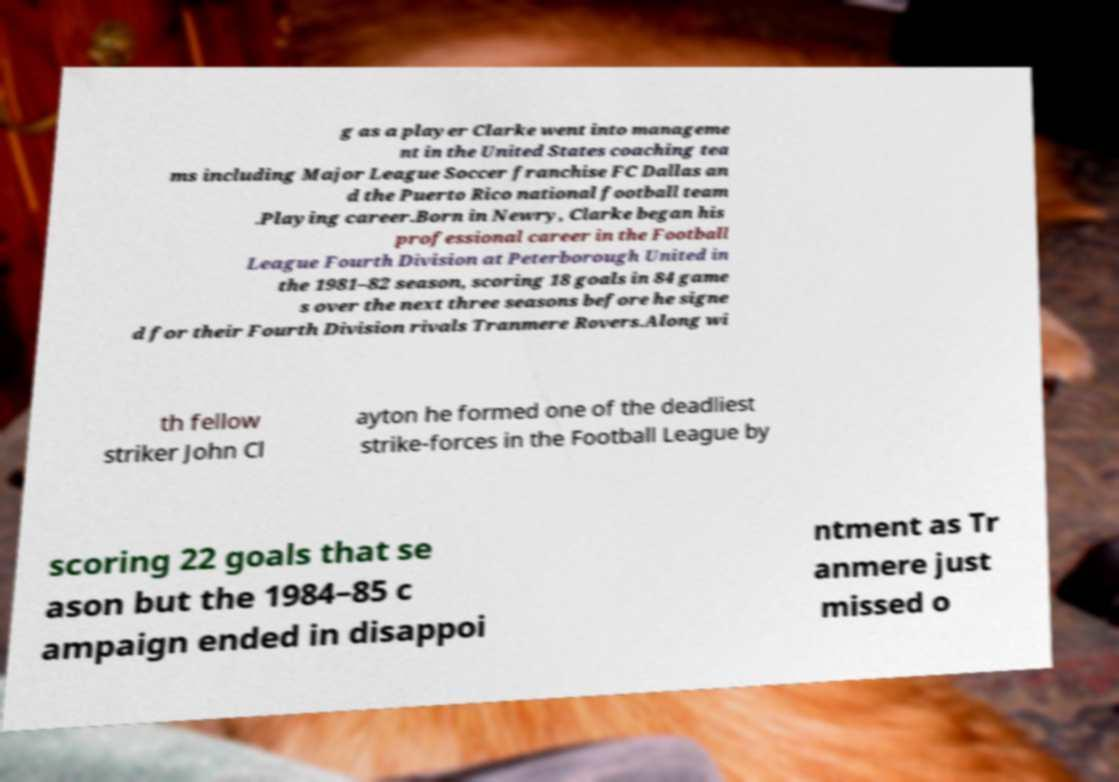Could you assist in decoding the text presented in this image and type it out clearly? g as a player Clarke went into manageme nt in the United States coaching tea ms including Major League Soccer franchise FC Dallas an d the Puerto Rico national football team .Playing career.Born in Newry, Clarke began his professional career in the Football League Fourth Division at Peterborough United in the 1981–82 season, scoring 18 goals in 84 game s over the next three seasons before he signe d for their Fourth Division rivals Tranmere Rovers.Along wi th fellow striker John Cl ayton he formed one of the deadliest strike-forces in the Football League by scoring 22 goals that se ason but the 1984–85 c ampaign ended in disappoi ntment as Tr anmere just missed o 